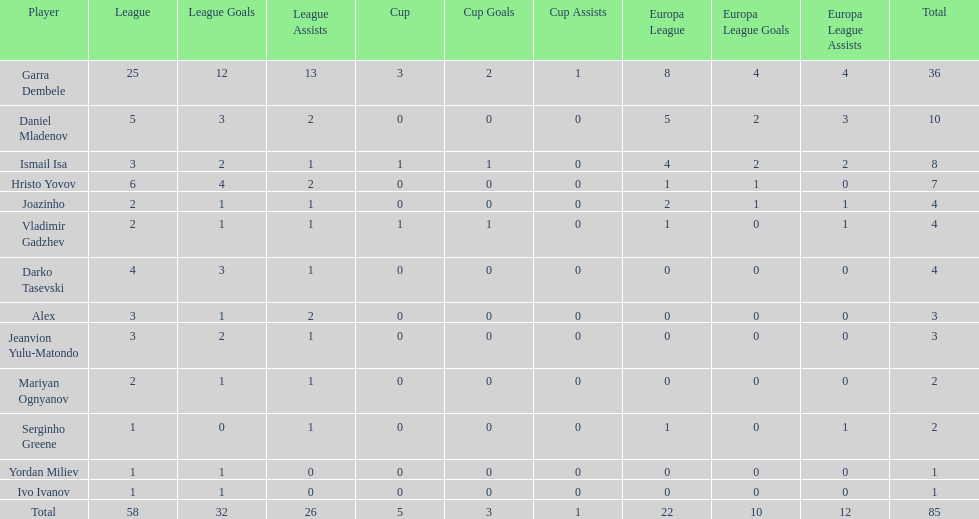Parse the full table. {'header': ['Player', 'League', 'League Goals', 'League Assists', 'Cup', 'Cup Goals', 'Cup Assists', 'Europa League', 'Europa League Goals', 'Europa League Assists', 'Total'], 'rows': [['Garra Dembele', '25', '12', '13', '3', '2', '1', '8', '4', '4', '36'], ['Daniel Mladenov', '5', '3', '2', '0', '0', '0', '5', '2', '3', '10'], ['Ismail Isa', '3', '2', '1', '1', '1', '0', '4', '2', '2', '8'], ['Hristo Yovov', '6', '4', '2', '0', '0', '0', '1', '1', '0', '7'], ['Joazinho', '2', '1', '1', '0', '0', '0', '2', '1', '1', '4'], ['Vladimir Gadzhev', '2', '1', '1', '1', '1', '0', '1', '0', '1', '4'], ['Darko Tasevski', '4', '3', '1', '0', '0', '0', '0', '0', '0', '4'], ['Alex', '3', '1', '2', '0', '0', '0', '0', '0', '0', '3'], ['Jeanvion Yulu-Matondo', '3', '2', '1', '0', '0', '0', '0', '0', '0', '3'], ['Mariyan Ognyanov', '2', '1', '1', '0', '0', '0', '0', '0', '0', '2'], ['Serginho Greene', '1', '0', '1', '0', '0', '0', '1', '0', '1', '2'], ['Yordan Miliev', '1', '1', '0', '0', '0', '0', '0', '0', '0', '1'], ['Ivo Ivanov', '1', '1', '0', '0', '0', '0', '0', '0', '0', '1'], ['Total', '58', '32', '26', '5', '3', '1', '22', '10', '12', '85']]} Which players only scored one goal? Serginho Greene, Yordan Miliev, Ivo Ivanov. 